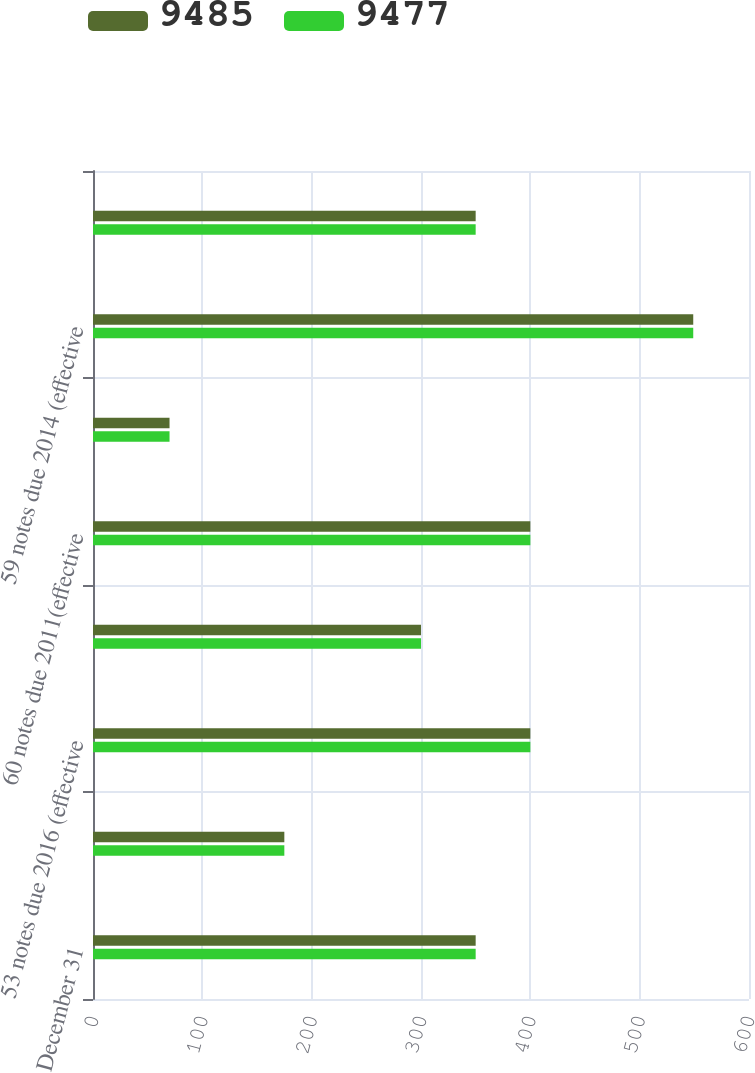Convert chart to OTSL. <chart><loc_0><loc_0><loc_500><loc_500><stacked_bar_chart><ecel><fcel>December 31<fcel>89 debentures due 2011<fcel>53 notes due 2016 (effective<fcel>60 notes due 2035 (effective<fcel>60 notes due 2011(effective<fcel>84 notes due 2012 (effective<fcel>59 notes due 2014 (effective<fcel>65 notes due 2016 (effective<nl><fcel>9485<fcel>350<fcel>175<fcel>400<fcel>300<fcel>400<fcel>70<fcel>549<fcel>350<nl><fcel>9477<fcel>350<fcel>175<fcel>400<fcel>300<fcel>400<fcel>70<fcel>549<fcel>350<nl></chart> 